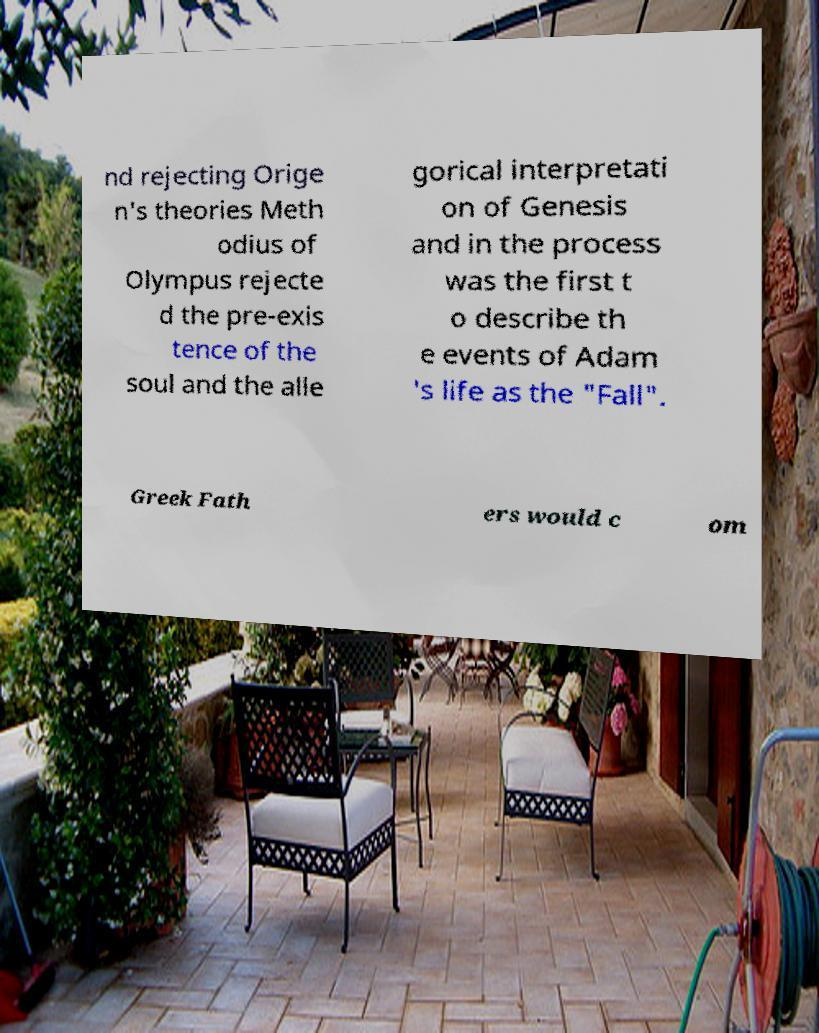What messages or text are displayed in this image? I need them in a readable, typed format. nd rejecting Orige n's theories Meth odius of Olympus rejecte d the pre-exis tence of the soul and the alle gorical interpretati on of Genesis and in the process was the first t o describe th e events of Adam 's life as the "Fall". Greek Fath ers would c om 